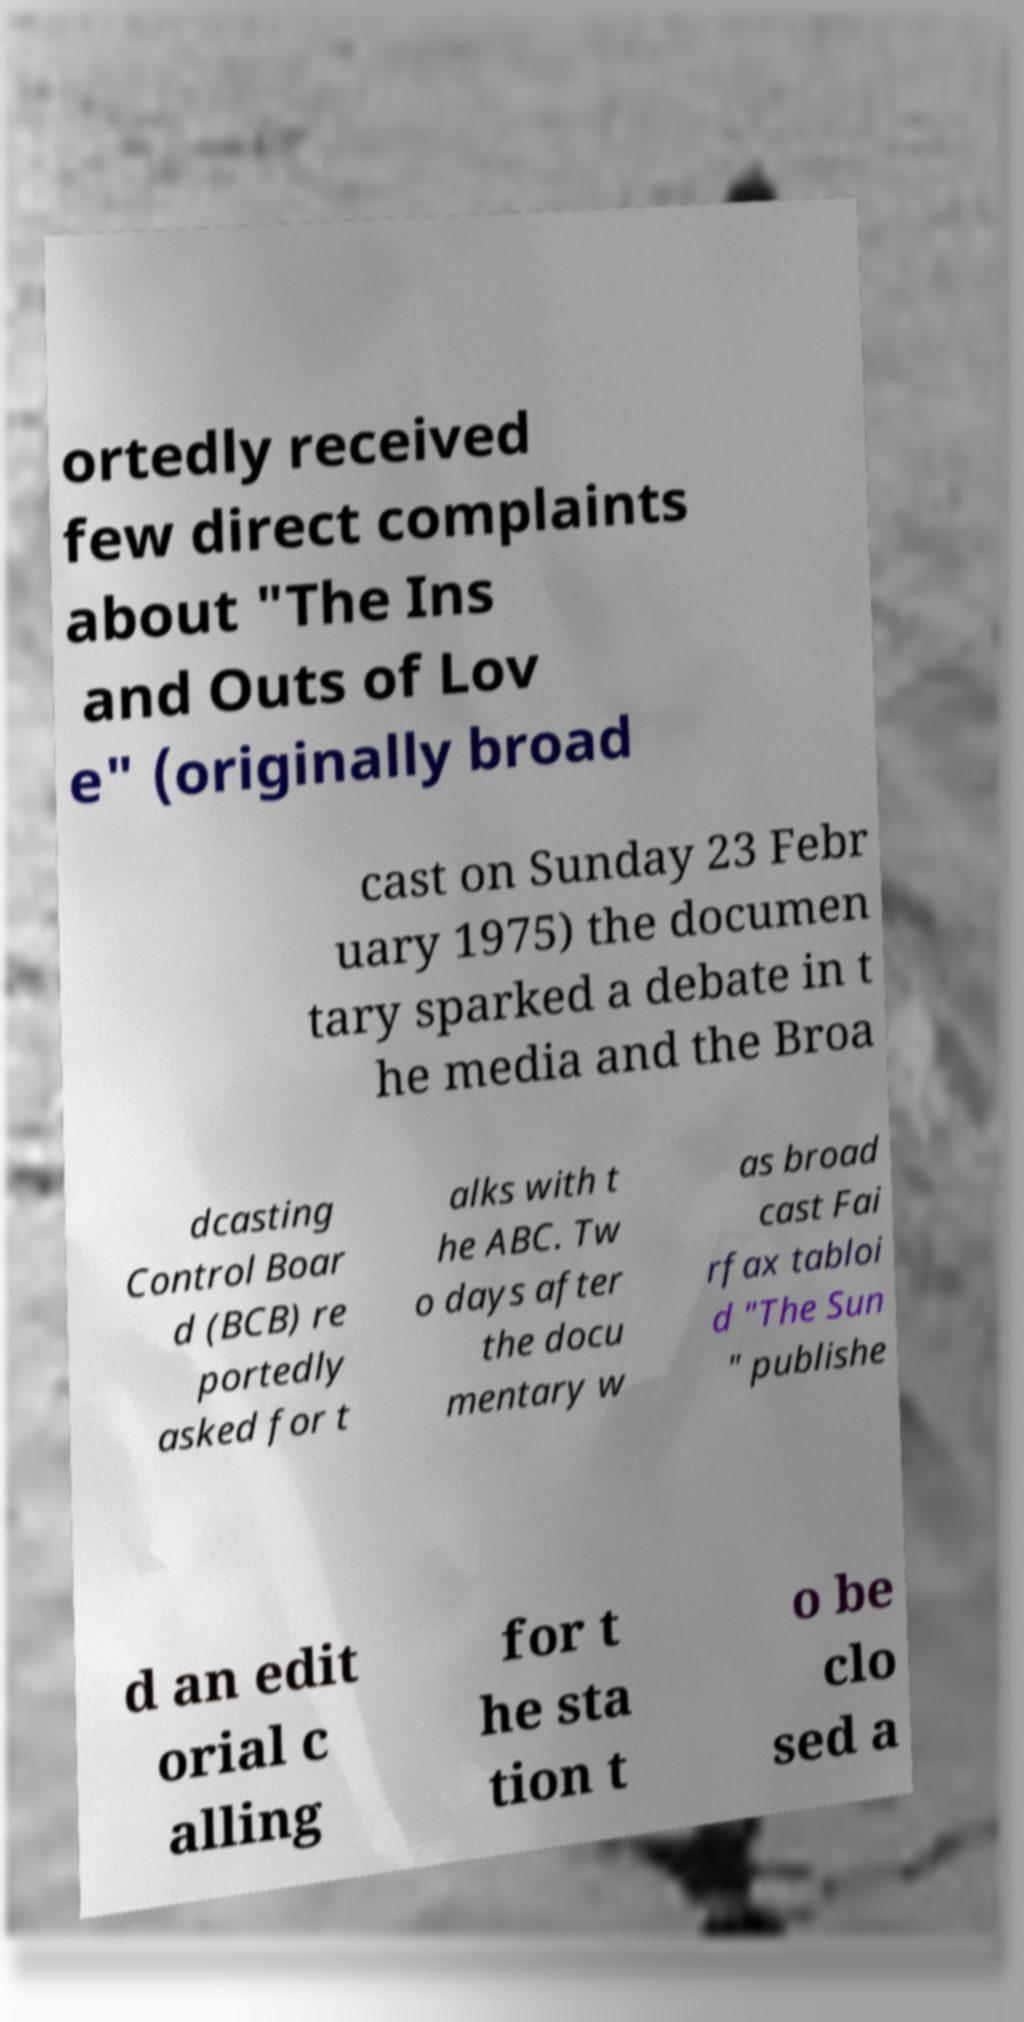Please identify and transcribe the text found in this image. ortedly received few direct complaints about "The Ins and Outs of Lov e" (originally broad cast on Sunday 23 Febr uary 1975) the documen tary sparked a debate in t he media and the Broa dcasting Control Boar d (BCB) re portedly asked for t alks with t he ABC. Tw o days after the docu mentary w as broad cast Fai rfax tabloi d "The Sun " publishe d an edit orial c alling for t he sta tion t o be clo sed a 